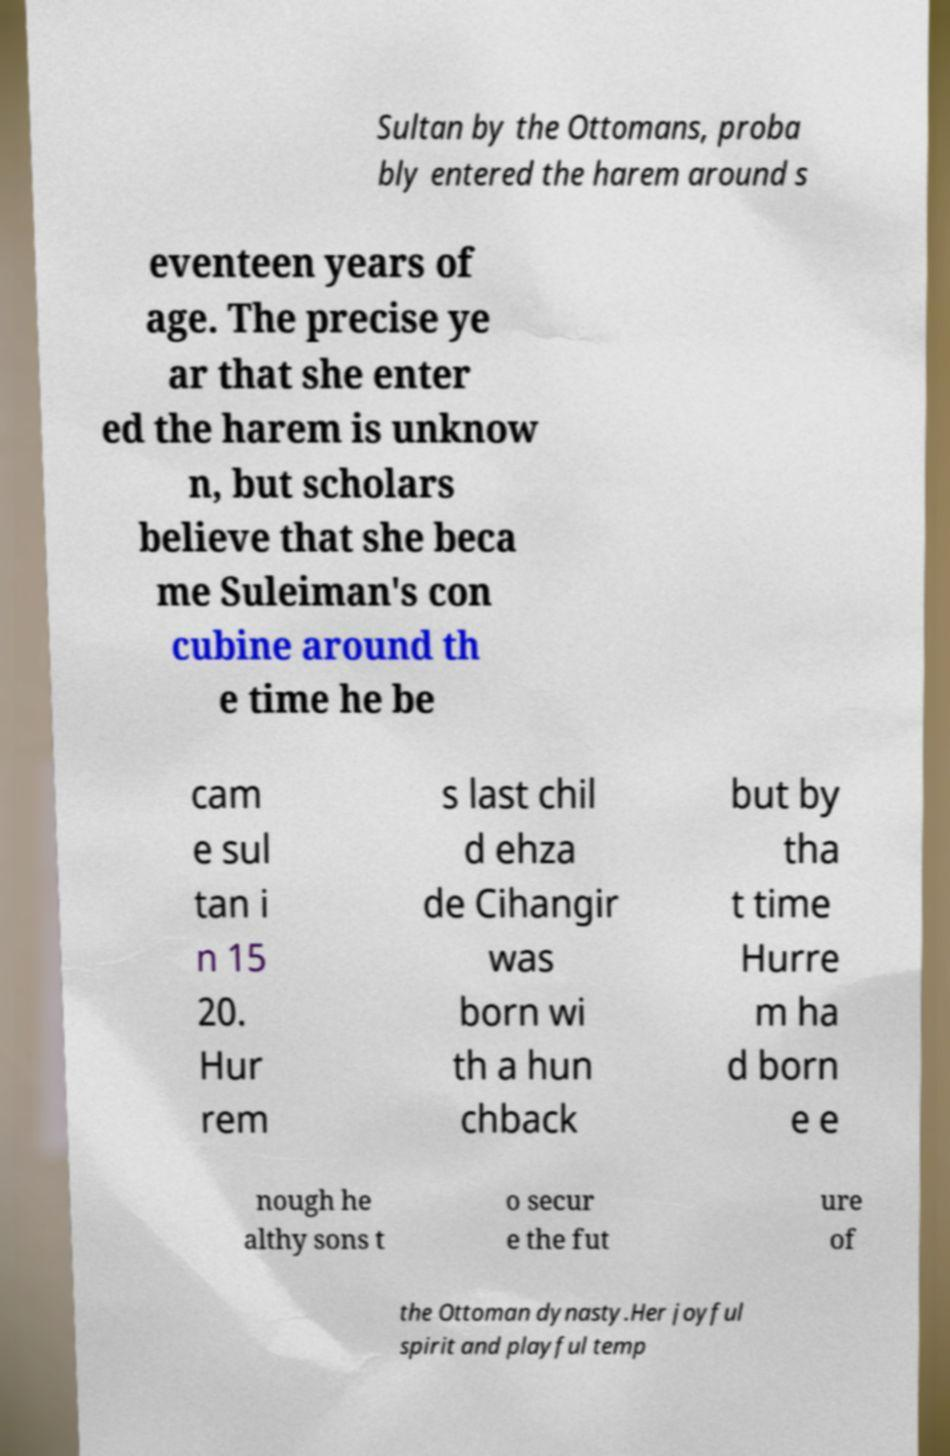For documentation purposes, I need the text within this image transcribed. Could you provide that? Sultan by the Ottomans, proba bly entered the harem around s eventeen years of age. The precise ye ar that she enter ed the harem is unknow n, but scholars believe that she beca me Suleiman's con cubine around th e time he be cam e sul tan i n 15 20. Hur rem s last chil d ehza de Cihangir was born wi th a hun chback but by tha t time Hurre m ha d born e e nough he althy sons t o secur e the fut ure of the Ottoman dynasty.Her joyful spirit and playful temp 